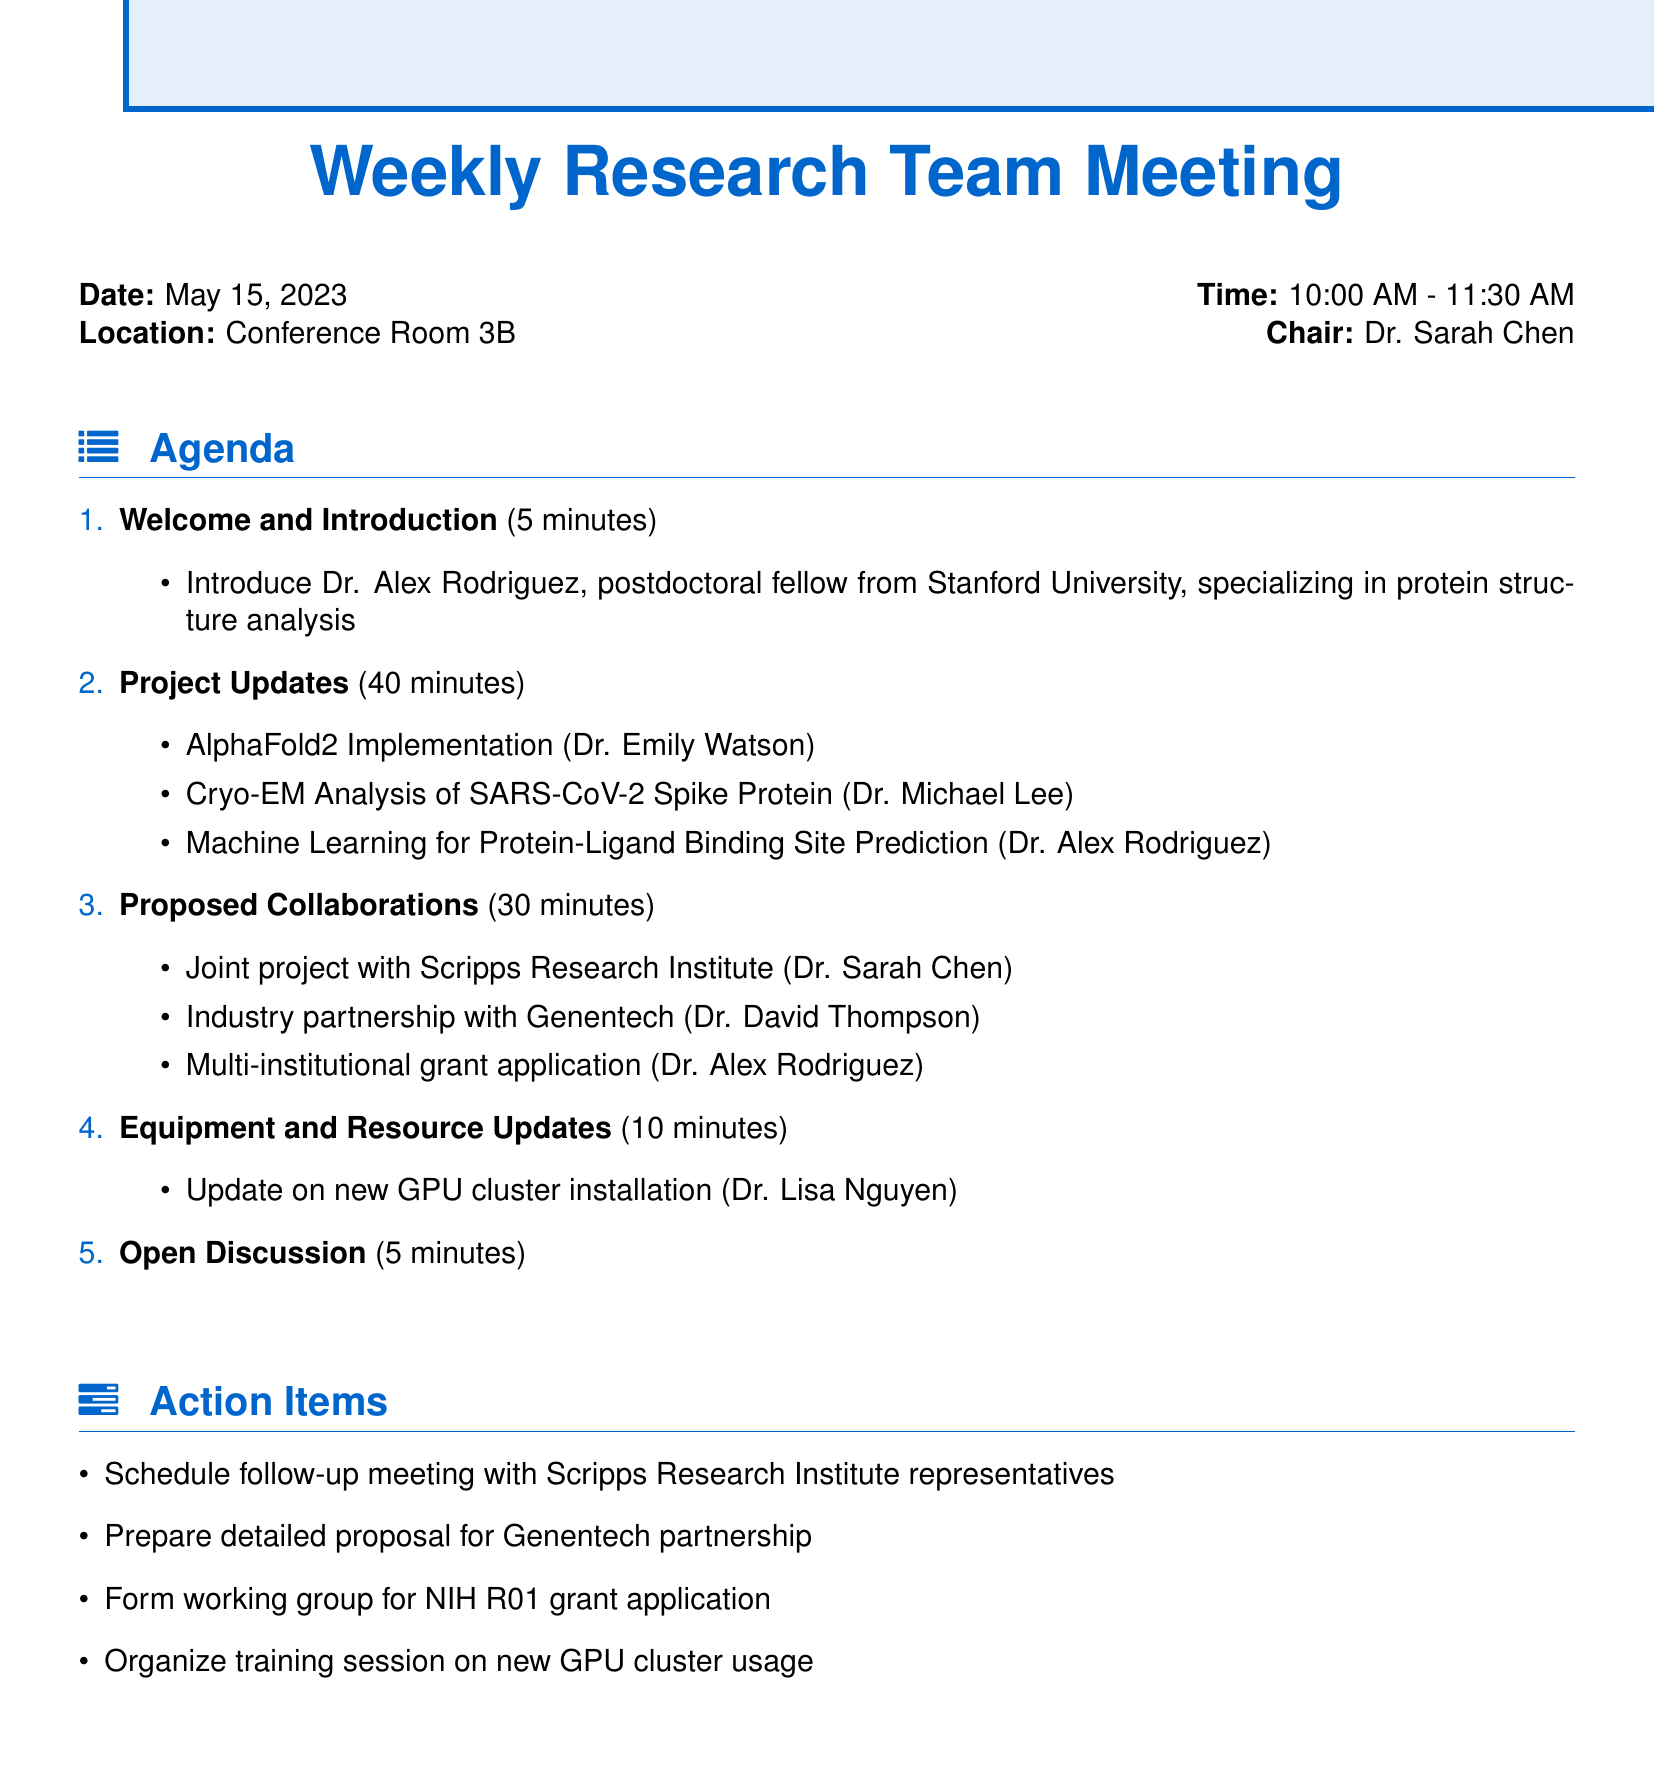What is the date of the meeting? The date of the meeting is clearly stated in the document.
Answer: May 15, 2023 Who is the chair of the meeting? The chair's name is mentioned in the meeting details section.
Answer: Dr. Sarah Chen What is the duration of the 'Project Updates' agenda item? The duration for 'Project Updates' is specified in the agenda items section.
Answer: 40 minutes Which project is Dr. Alex Rodriguez presenting? The specific project presented by Dr. Alex Rodriguez is listed under project updates.
Answer: Machine Learning for Protein-Ligand Binding Site Prediction What collaboration is proposed with Scripps Research Institute? The document outlines collaboration proposals, including specifics about Scripps Research.
Answer: Joint project with Scripps Research Institute How long is the 'Open Discussion' segment? The duration of the 'Open Discussion' is provided in the agenda section.
Answer: 5 minutes Who will update on the new GPU cluster installation? The presenter for the equipment update is mentioned in the agenda items.
Answer: Dr. Lisa Nguyen What action item involves Genentech? The action items listed refer to actions to be taken regarding Genentech.
Answer: Prepare detailed proposal for Genentech partnership 